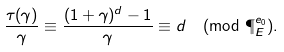Convert formula to latex. <formula><loc_0><loc_0><loc_500><loc_500>\frac { \tau ( \gamma ) } { \gamma } \equiv \frac { ( 1 + \gamma ) ^ { d } - 1 } { \gamma } \equiv d \pmod { \P _ { E } ^ { e _ { 0 } } } .</formula> 